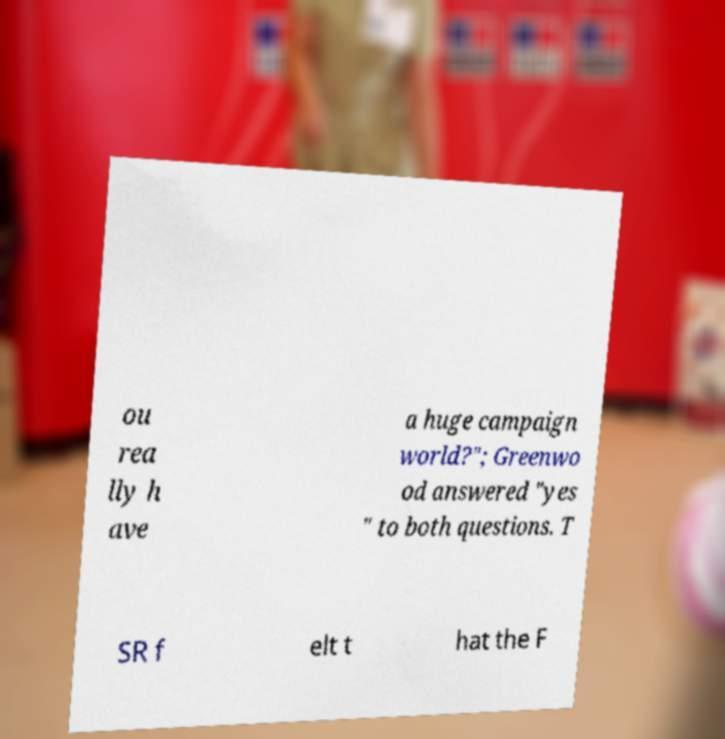There's text embedded in this image that I need extracted. Can you transcribe it verbatim? ou rea lly h ave a huge campaign world?"; Greenwo od answered "yes " to both questions. T SR f elt t hat the F 